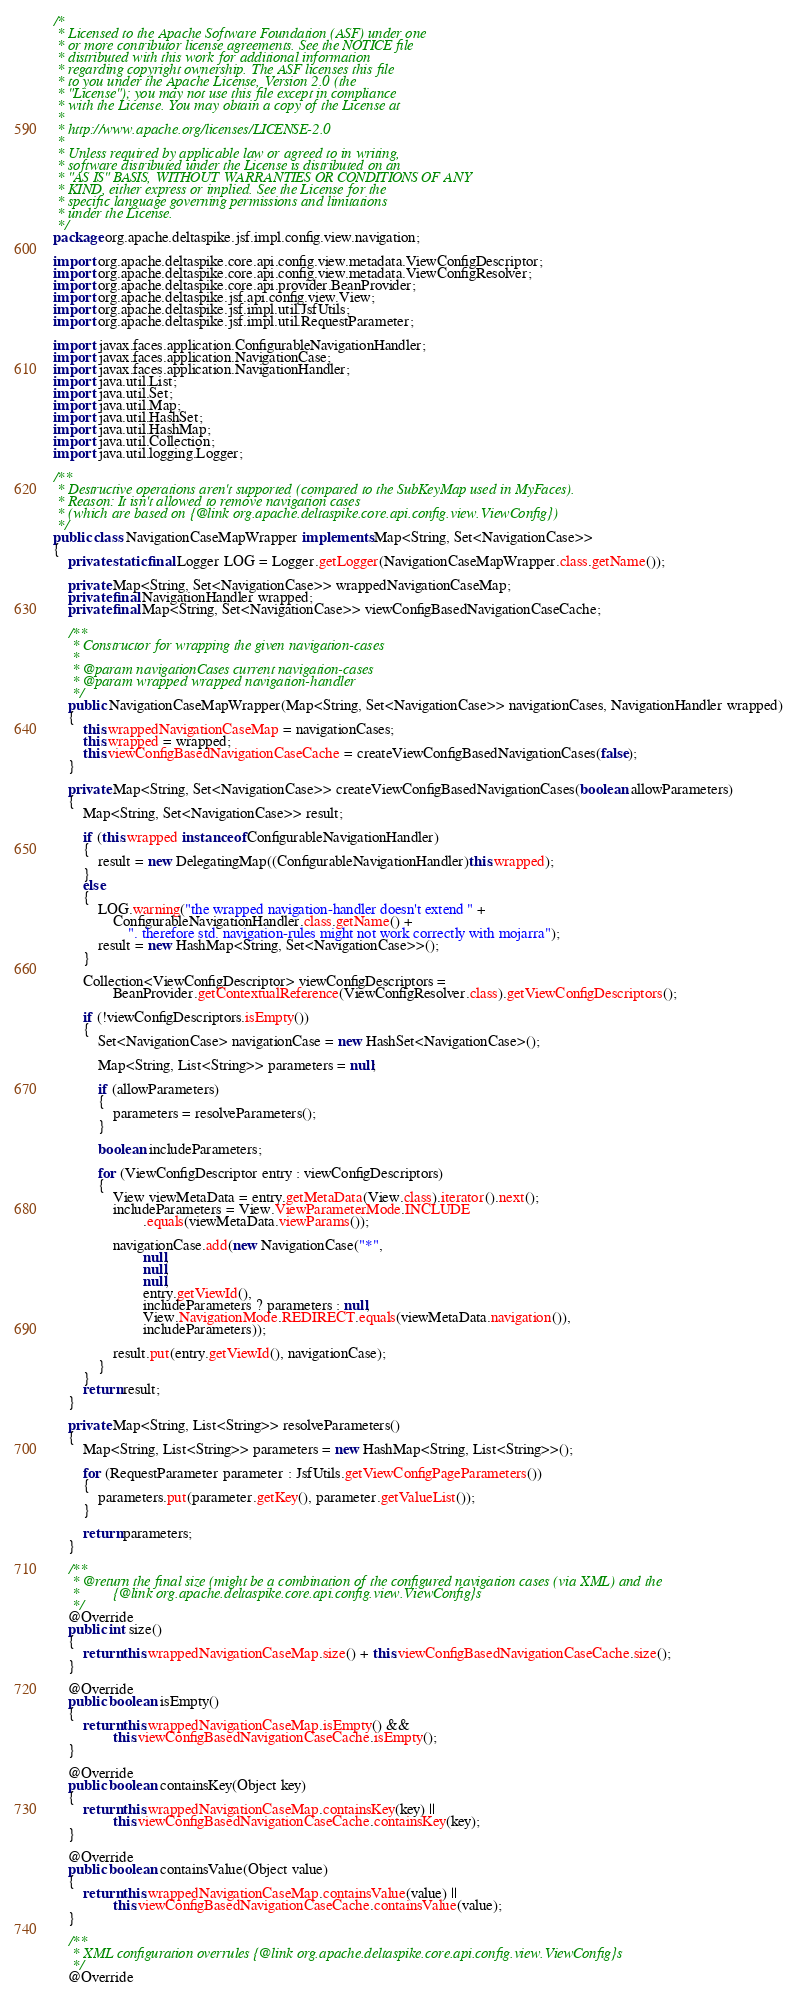Convert code to text. <code><loc_0><loc_0><loc_500><loc_500><_Java_>/*
 * Licensed to the Apache Software Foundation (ASF) under one
 * or more contributor license agreements. See the NOTICE file
 * distributed with this work for additional information
 * regarding copyright ownership. The ASF licenses this file
 * to you under the Apache License, Version 2.0 (the
 * "License"); you may not use this file except in compliance
 * with the License. You may obtain a copy of the License at
 *
 * http://www.apache.org/licenses/LICENSE-2.0
 *
 * Unless required by applicable law or agreed to in writing,
 * software distributed under the License is distributed on an
 * "AS IS" BASIS, WITHOUT WARRANTIES OR CONDITIONS OF ANY
 * KIND, either express or implied. See the License for the
 * specific language governing permissions and limitations
 * under the License.
 */
package org.apache.deltaspike.jsf.impl.config.view.navigation;

import org.apache.deltaspike.core.api.config.view.metadata.ViewConfigDescriptor;
import org.apache.deltaspike.core.api.config.view.metadata.ViewConfigResolver;
import org.apache.deltaspike.core.api.provider.BeanProvider;
import org.apache.deltaspike.jsf.api.config.view.View;
import org.apache.deltaspike.jsf.impl.util.JsfUtils;
import org.apache.deltaspike.jsf.impl.util.RequestParameter;

import javax.faces.application.ConfigurableNavigationHandler;
import javax.faces.application.NavigationCase;
import javax.faces.application.NavigationHandler;
import java.util.List;
import java.util.Set;
import java.util.Map;
import java.util.HashSet;
import java.util.HashMap;
import java.util.Collection;
import java.util.logging.Logger;

/**
 * Destructive operations aren't supported (compared to the SubKeyMap used in MyFaces).
 * Reason: It isn't allowed to remove navigation cases
 * (which are based on {@link org.apache.deltaspike.core.api.config.view.ViewConfig})
 */
public class NavigationCaseMapWrapper implements Map<String, Set<NavigationCase>>
{
    private static final Logger LOG = Logger.getLogger(NavigationCaseMapWrapper.class.getName());

    private Map<String, Set<NavigationCase>> wrappedNavigationCaseMap;
    private final NavigationHandler wrapped;
    private final Map<String, Set<NavigationCase>> viewConfigBasedNavigationCaseCache;

    /**
     * Constructor for wrapping the given navigation-cases
     *
     * @param navigationCases current navigation-cases
     * @param wrapped wrapped navigation-handler
     */
    public NavigationCaseMapWrapper(Map<String, Set<NavigationCase>> navigationCases, NavigationHandler wrapped)
    {
        this.wrappedNavigationCaseMap = navigationCases;
        this.wrapped = wrapped;
        this.viewConfigBasedNavigationCaseCache = createViewConfigBasedNavigationCases(false);
    }

    private Map<String, Set<NavigationCase>> createViewConfigBasedNavigationCases(boolean allowParameters)
    {
        Map<String, Set<NavigationCase>> result;

        if (this.wrapped instanceof ConfigurableNavigationHandler)
        {
            result = new DelegatingMap((ConfigurableNavigationHandler)this.wrapped);
        }
        else
        {
            LOG.warning("the wrapped navigation-handler doesn't extend " +
                ConfigurableNavigationHandler.class.getName() +
                    ". therefore std. navigation-rules might not work correctly with mojarra");
            result = new HashMap<String, Set<NavigationCase>>();
        }

        Collection<ViewConfigDescriptor> viewConfigDescriptors =
                BeanProvider.getContextualReference(ViewConfigResolver.class).getViewConfigDescriptors();

        if (!viewConfigDescriptors.isEmpty())
        {
            Set<NavigationCase> navigationCase = new HashSet<NavigationCase>();

            Map<String, List<String>> parameters = null;

            if (allowParameters)
            {
                parameters = resolveParameters();
            }

            boolean includeParameters;

            for (ViewConfigDescriptor entry : viewConfigDescriptors)
            {
                View viewMetaData = entry.getMetaData(View.class).iterator().next();
                includeParameters = View.ViewParameterMode.INCLUDE
                        .equals(viewMetaData.viewParams());

                navigationCase.add(new NavigationCase("*",
                        null,
                        null,
                        null,
                        entry.getViewId(),
                        includeParameters ? parameters : null,
                        View.NavigationMode.REDIRECT.equals(viewMetaData.navigation()),
                        includeParameters));

                result.put(entry.getViewId(), navigationCase);
            }
        }
        return result;
    }

    private Map<String, List<String>> resolveParameters()
    {
        Map<String, List<String>> parameters = new HashMap<String, List<String>>();

        for (RequestParameter parameter : JsfUtils.getViewConfigPageParameters())
        {
            parameters.put(parameter.getKey(), parameter.getValueList());
        }

        return parameters;
    }

    /**
     * @return the final size (might be a combination of the configured navigation cases (via XML) and the
     *         {@link org.apache.deltaspike.core.api.config.view.ViewConfig}s
     */
    @Override
    public int size()
    {
        return this.wrappedNavigationCaseMap.size() + this.viewConfigBasedNavigationCaseCache.size();
    }

    @Override
    public boolean isEmpty()
    {
        return this.wrappedNavigationCaseMap.isEmpty() &&
                this.viewConfigBasedNavigationCaseCache.isEmpty();
    }

    @Override
    public boolean containsKey(Object key)
    {
        return this.wrappedNavigationCaseMap.containsKey(key) ||
                this.viewConfigBasedNavigationCaseCache.containsKey(key);
    }

    @Override
    public boolean containsValue(Object value)
    {
        return this.wrappedNavigationCaseMap.containsValue(value) ||
                this.viewConfigBasedNavigationCaseCache.containsValue(value);
    }

    /**
     * XML configuration overrules {@link org.apache.deltaspike.core.api.config.view.ViewConfig}s
     */
    @Override</code> 